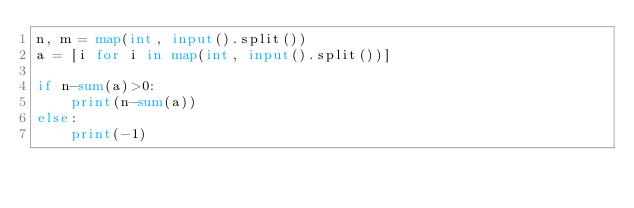Convert code to text. <code><loc_0><loc_0><loc_500><loc_500><_Python_>n, m = map(int, input().split())
a = [i for i in map(int, input().split())]

if n-sum(a)>0:
    print(n-sum(a))
else:
    print(-1)</code> 